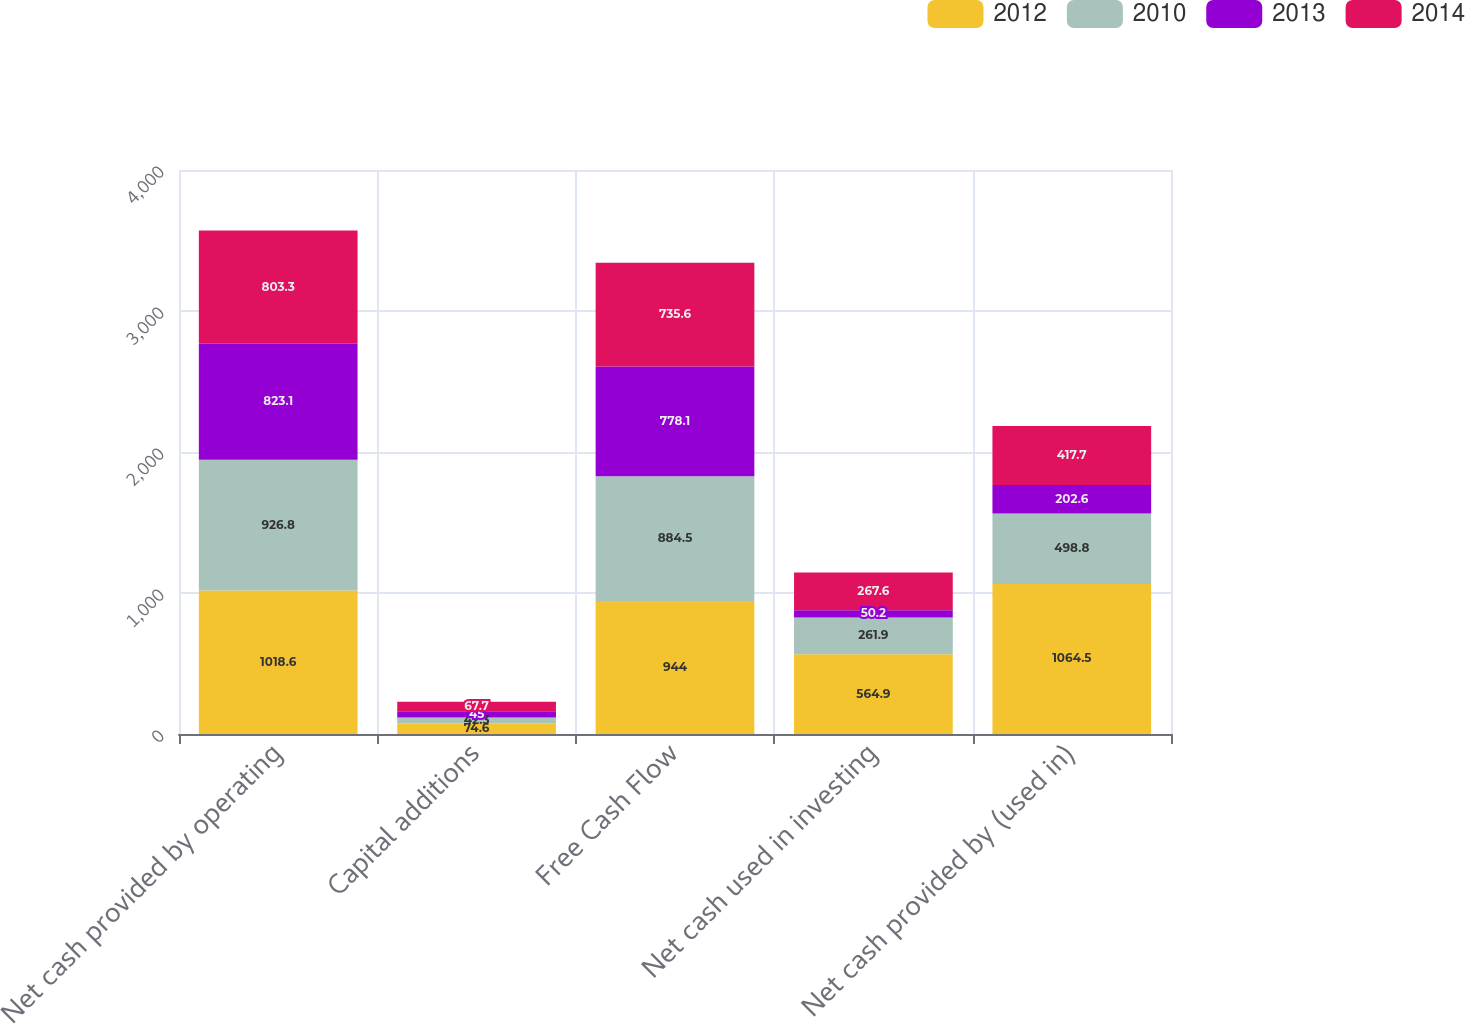Convert chart to OTSL. <chart><loc_0><loc_0><loc_500><loc_500><stacked_bar_chart><ecel><fcel>Net cash provided by operating<fcel>Capital additions<fcel>Free Cash Flow<fcel>Net cash used in investing<fcel>Net cash provided by (used in)<nl><fcel>2012<fcel>1018.6<fcel>74.6<fcel>944<fcel>564.9<fcel>1064.5<nl><fcel>2010<fcel>926.8<fcel>42.3<fcel>884.5<fcel>261.9<fcel>498.8<nl><fcel>2013<fcel>823.1<fcel>45<fcel>778.1<fcel>50.2<fcel>202.6<nl><fcel>2014<fcel>803.3<fcel>67.7<fcel>735.6<fcel>267.6<fcel>417.7<nl></chart> 